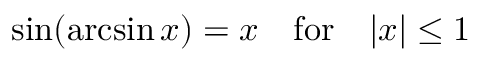Convert formula to latex. <formula><loc_0><loc_0><loc_500><loc_500>\sin ( \arcsin x ) = x \quad f o r \quad | x | \leq 1</formula> 